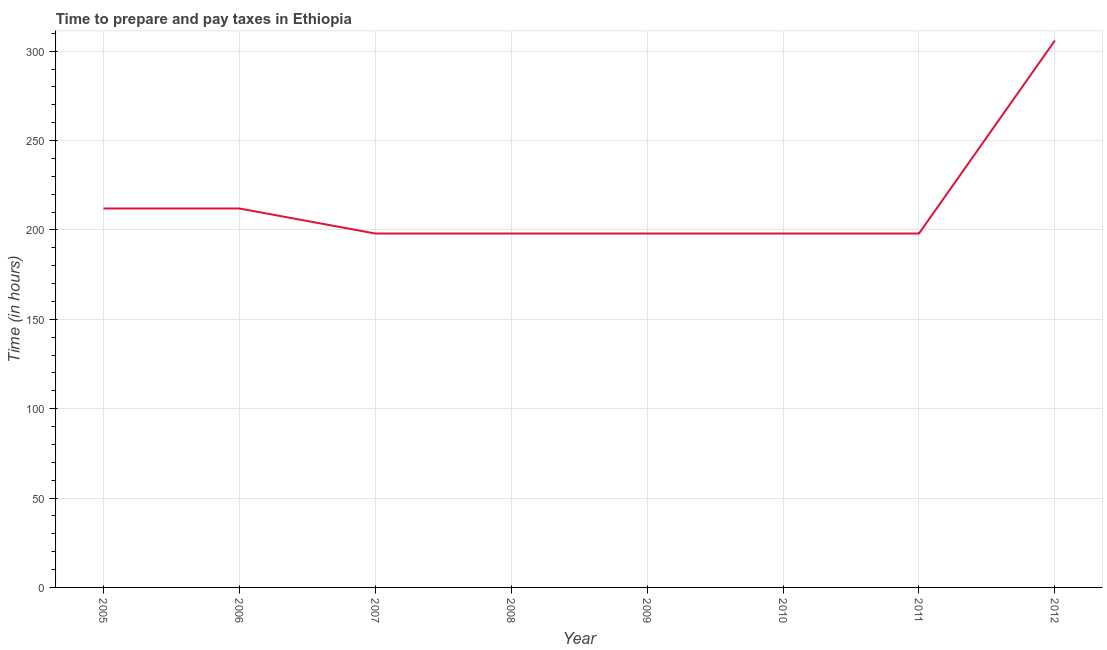What is the time to prepare and pay taxes in 2006?
Ensure brevity in your answer.  212. Across all years, what is the maximum time to prepare and pay taxes?
Your response must be concise. 306. Across all years, what is the minimum time to prepare and pay taxes?
Make the answer very short. 198. In which year was the time to prepare and pay taxes maximum?
Provide a short and direct response. 2012. In which year was the time to prepare and pay taxes minimum?
Give a very brief answer. 2007. What is the sum of the time to prepare and pay taxes?
Provide a short and direct response. 1720. What is the difference between the time to prepare and pay taxes in 2008 and 2012?
Keep it short and to the point. -108. What is the average time to prepare and pay taxes per year?
Offer a terse response. 215. What is the median time to prepare and pay taxes?
Your answer should be compact. 198. What is the ratio of the time to prepare and pay taxes in 2005 to that in 2010?
Your answer should be compact. 1.07. Is the time to prepare and pay taxes in 2005 less than that in 2011?
Your response must be concise. No. What is the difference between the highest and the second highest time to prepare and pay taxes?
Provide a short and direct response. 94. Is the sum of the time to prepare and pay taxes in 2006 and 2012 greater than the maximum time to prepare and pay taxes across all years?
Your response must be concise. Yes. What is the difference between the highest and the lowest time to prepare and pay taxes?
Provide a succinct answer. 108. Does the time to prepare and pay taxes monotonically increase over the years?
Give a very brief answer. No. What is the difference between two consecutive major ticks on the Y-axis?
Keep it short and to the point. 50. Are the values on the major ticks of Y-axis written in scientific E-notation?
Your answer should be very brief. No. Does the graph contain any zero values?
Your answer should be compact. No. What is the title of the graph?
Your answer should be compact. Time to prepare and pay taxes in Ethiopia. What is the label or title of the X-axis?
Make the answer very short. Year. What is the label or title of the Y-axis?
Keep it short and to the point. Time (in hours). What is the Time (in hours) in 2005?
Ensure brevity in your answer.  212. What is the Time (in hours) in 2006?
Offer a very short reply. 212. What is the Time (in hours) in 2007?
Provide a succinct answer. 198. What is the Time (in hours) in 2008?
Your response must be concise. 198. What is the Time (in hours) of 2009?
Your response must be concise. 198. What is the Time (in hours) in 2010?
Your answer should be very brief. 198. What is the Time (in hours) of 2011?
Ensure brevity in your answer.  198. What is the Time (in hours) of 2012?
Offer a very short reply. 306. What is the difference between the Time (in hours) in 2005 and 2006?
Provide a succinct answer. 0. What is the difference between the Time (in hours) in 2005 and 2008?
Provide a short and direct response. 14. What is the difference between the Time (in hours) in 2005 and 2009?
Offer a very short reply. 14. What is the difference between the Time (in hours) in 2005 and 2010?
Your response must be concise. 14. What is the difference between the Time (in hours) in 2005 and 2012?
Offer a very short reply. -94. What is the difference between the Time (in hours) in 2006 and 2008?
Offer a very short reply. 14. What is the difference between the Time (in hours) in 2006 and 2009?
Your answer should be very brief. 14. What is the difference between the Time (in hours) in 2006 and 2010?
Ensure brevity in your answer.  14. What is the difference between the Time (in hours) in 2006 and 2012?
Provide a short and direct response. -94. What is the difference between the Time (in hours) in 2007 and 2008?
Offer a very short reply. 0. What is the difference between the Time (in hours) in 2007 and 2011?
Your response must be concise. 0. What is the difference between the Time (in hours) in 2007 and 2012?
Keep it short and to the point. -108. What is the difference between the Time (in hours) in 2008 and 2012?
Make the answer very short. -108. What is the difference between the Time (in hours) in 2009 and 2011?
Give a very brief answer. 0. What is the difference between the Time (in hours) in 2009 and 2012?
Offer a terse response. -108. What is the difference between the Time (in hours) in 2010 and 2011?
Offer a very short reply. 0. What is the difference between the Time (in hours) in 2010 and 2012?
Make the answer very short. -108. What is the difference between the Time (in hours) in 2011 and 2012?
Ensure brevity in your answer.  -108. What is the ratio of the Time (in hours) in 2005 to that in 2007?
Your answer should be compact. 1.07. What is the ratio of the Time (in hours) in 2005 to that in 2008?
Offer a terse response. 1.07. What is the ratio of the Time (in hours) in 2005 to that in 2009?
Ensure brevity in your answer.  1.07. What is the ratio of the Time (in hours) in 2005 to that in 2010?
Keep it short and to the point. 1.07. What is the ratio of the Time (in hours) in 2005 to that in 2011?
Provide a succinct answer. 1.07. What is the ratio of the Time (in hours) in 2005 to that in 2012?
Keep it short and to the point. 0.69. What is the ratio of the Time (in hours) in 2006 to that in 2007?
Your answer should be very brief. 1.07. What is the ratio of the Time (in hours) in 2006 to that in 2008?
Give a very brief answer. 1.07. What is the ratio of the Time (in hours) in 2006 to that in 2009?
Your answer should be compact. 1.07. What is the ratio of the Time (in hours) in 2006 to that in 2010?
Offer a very short reply. 1.07. What is the ratio of the Time (in hours) in 2006 to that in 2011?
Make the answer very short. 1.07. What is the ratio of the Time (in hours) in 2006 to that in 2012?
Provide a succinct answer. 0.69. What is the ratio of the Time (in hours) in 2007 to that in 2009?
Your response must be concise. 1. What is the ratio of the Time (in hours) in 2007 to that in 2010?
Make the answer very short. 1. What is the ratio of the Time (in hours) in 2007 to that in 2012?
Keep it short and to the point. 0.65. What is the ratio of the Time (in hours) in 2008 to that in 2012?
Your answer should be very brief. 0.65. What is the ratio of the Time (in hours) in 2009 to that in 2011?
Your response must be concise. 1. What is the ratio of the Time (in hours) in 2009 to that in 2012?
Offer a very short reply. 0.65. What is the ratio of the Time (in hours) in 2010 to that in 2012?
Provide a short and direct response. 0.65. What is the ratio of the Time (in hours) in 2011 to that in 2012?
Your answer should be very brief. 0.65. 